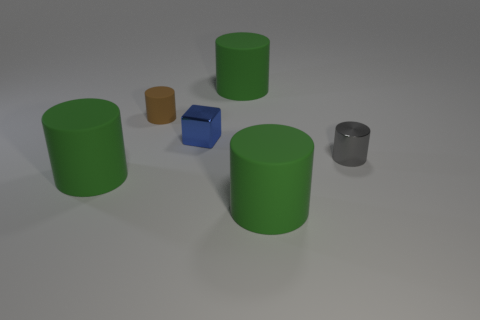Subtract all green cylinders. How many were subtracted if there are1green cylinders left? 2 Subtract all gray metal cylinders. How many cylinders are left? 4 Subtract all gray blocks. How many green cylinders are left? 3 Add 3 cylinders. How many objects exist? 9 Subtract all gray cylinders. How many cylinders are left? 4 Subtract 1 cubes. How many cubes are left? 0 Subtract all cylinders. How many objects are left? 1 Add 3 tiny blue objects. How many tiny blue objects are left? 4 Add 4 metal cylinders. How many metal cylinders exist? 5 Subtract 0 red balls. How many objects are left? 6 